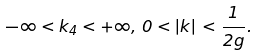Convert formula to latex. <formula><loc_0><loc_0><loc_500><loc_500>- \infty < k _ { 4 } < + \infty , \, 0 < { | k | } \, < \frac { 1 } { 2 g } .</formula> 